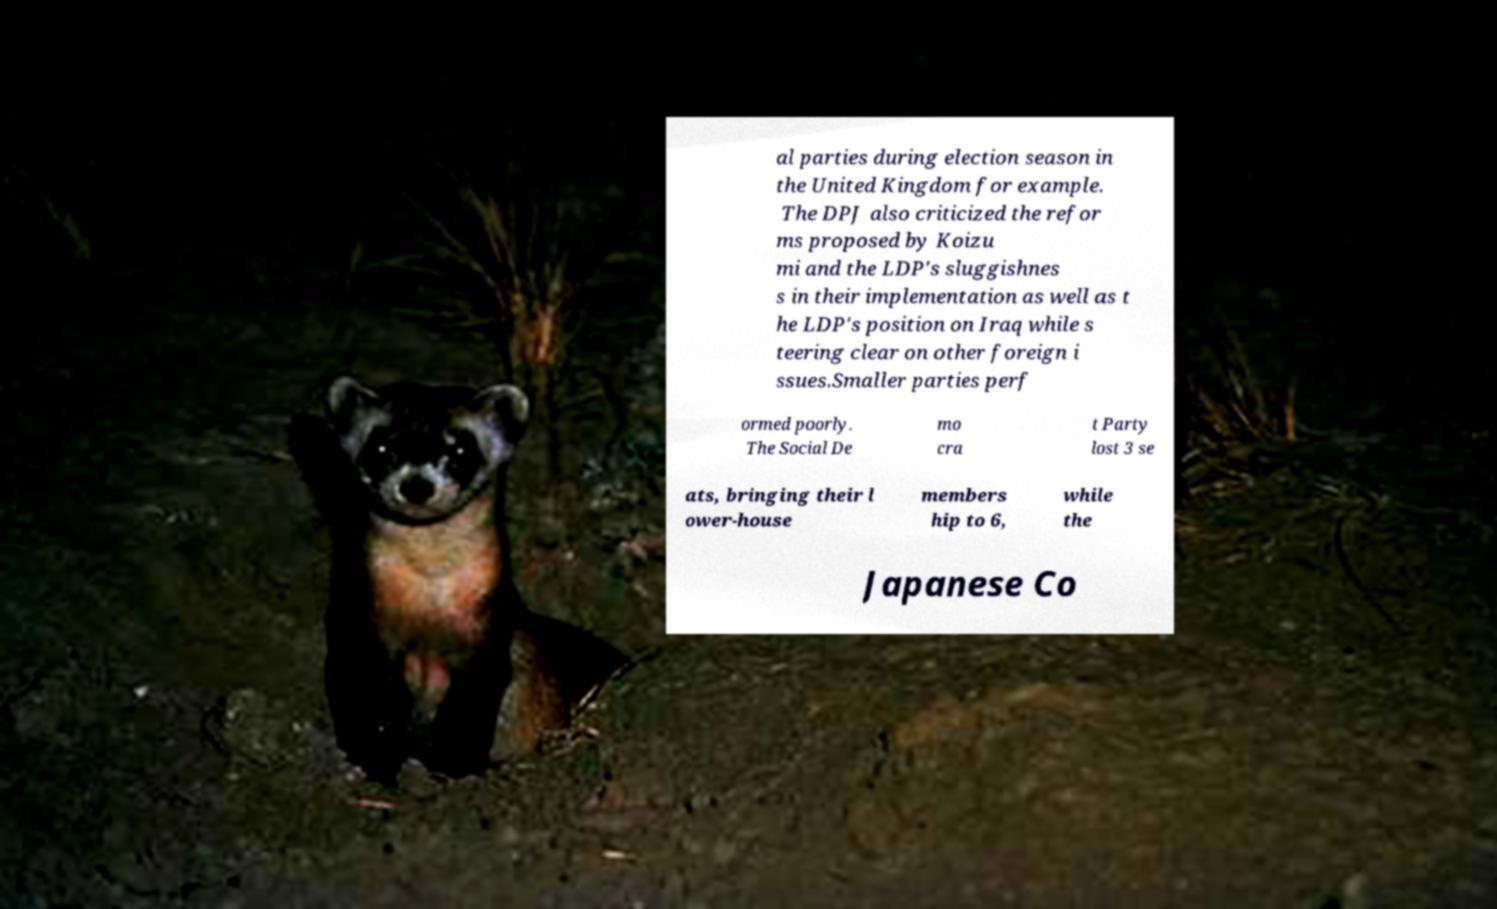For documentation purposes, I need the text within this image transcribed. Could you provide that? al parties during election season in the United Kingdom for example. The DPJ also criticized the refor ms proposed by Koizu mi and the LDP's sluggishnes s in their implementation as well as t he LDP's position on Iraq while s teering clear on other foreign i ssues.Smaller parties perf ormed poorly. The Social De mo cra t Party lost 3 se ats, bringing their l ower-house members hip to 6, while the Japanese Co 